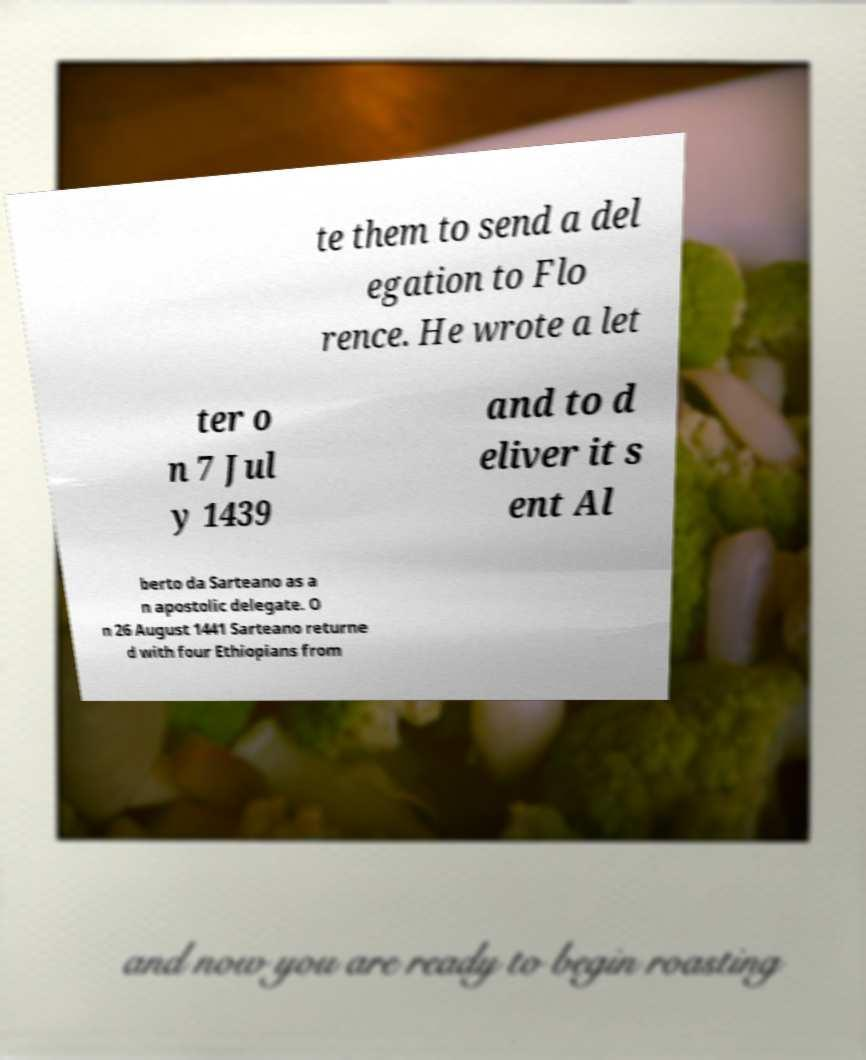Please identify and transcribe the text found in this image. te them to send a del egation to Flo rence. He wrote a let ter o n 7 Jul y 1439 and to d eliver it s ent Al berto da Sarteano as a n apostolic delegate. O n 26 August 1441 Sarteano returne d with four Ethiopians from 